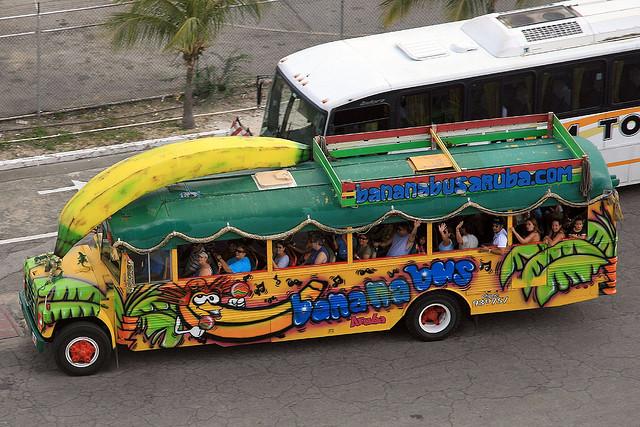What color are the windows on the white bus?
Give a very brief answer. Black. How long is the banana?
Answer briefly. 15 feet. How many people are in this photo?
Concise answer only. 20. Is the banana real?
Keep it brief. No. 